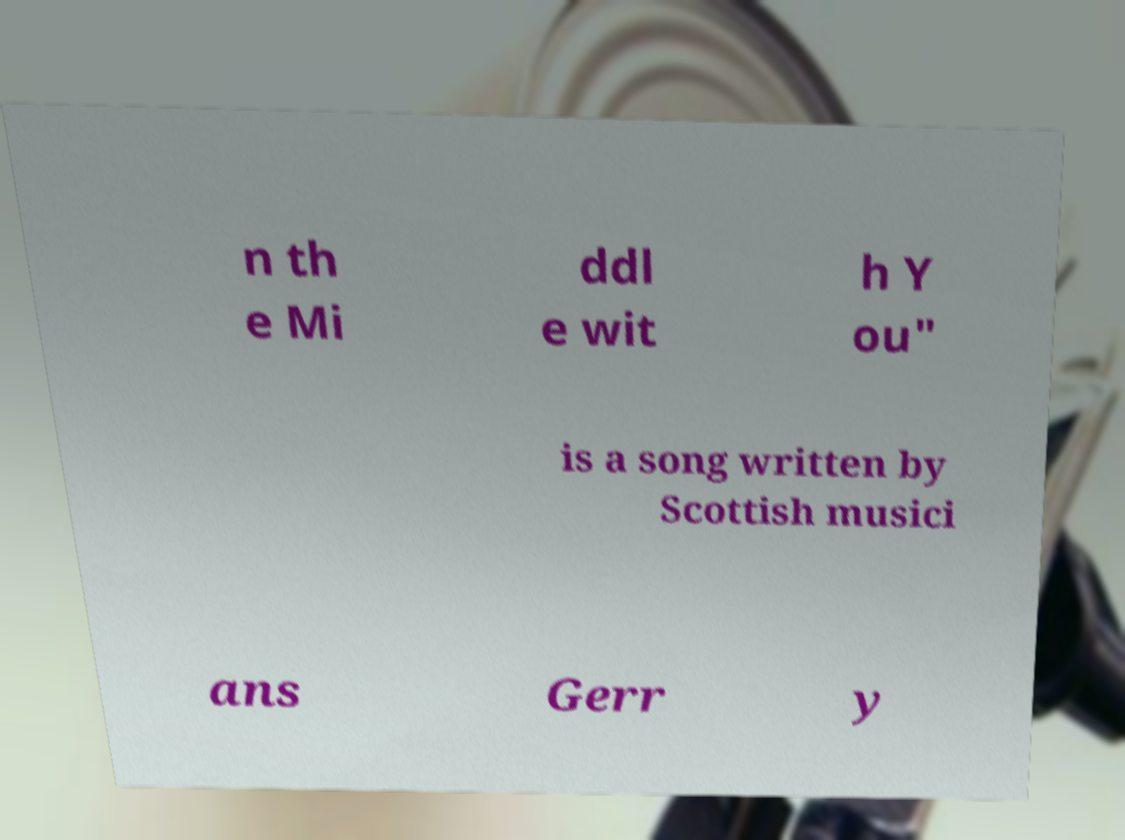Could you extract and type out the text from this image? n th e Mi ddl e wit h Y ou" is a song written by Scottish musici ans Gerr y 